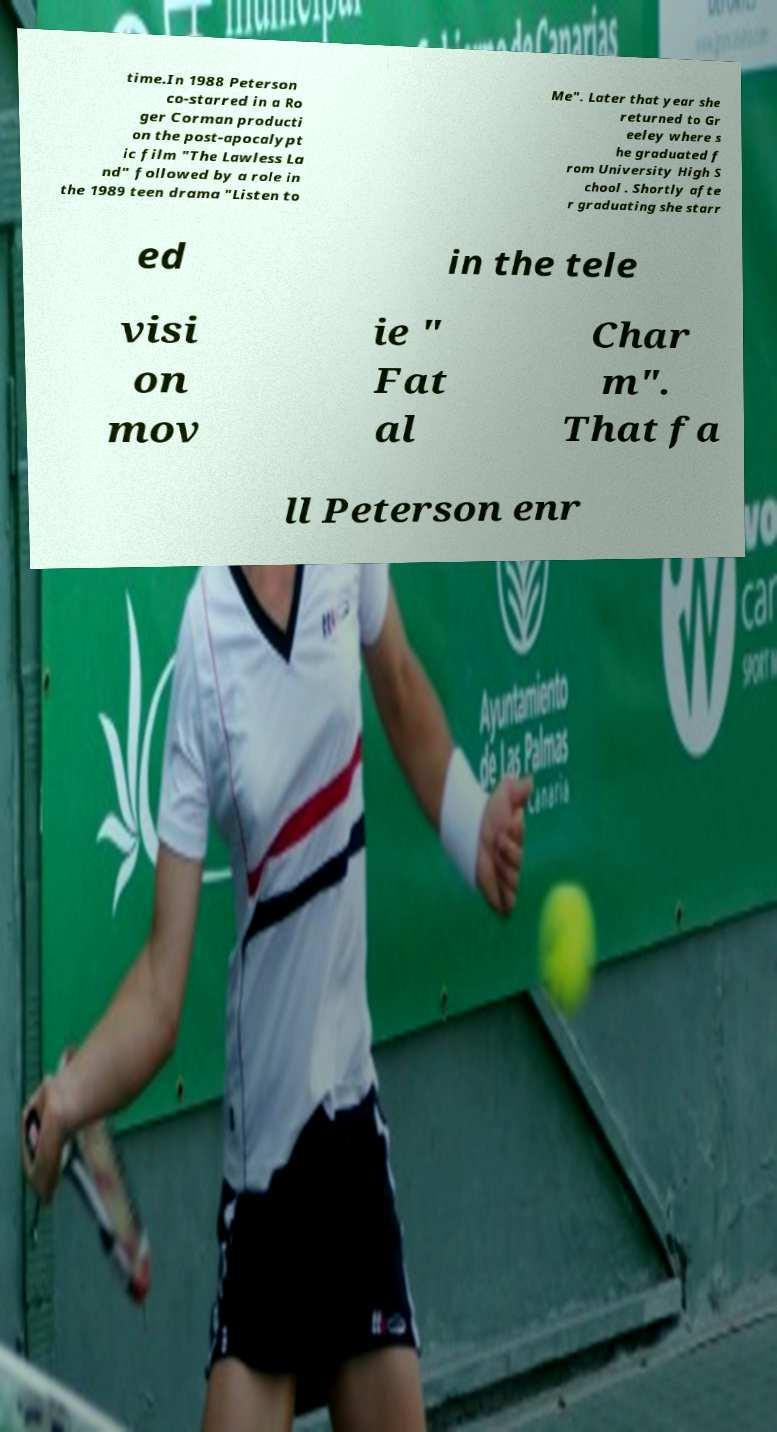Could you assist in decoding the text presented in this image and type it out clearly? time.In 1988 Peterson co-starred in a Ro ger Corman producti on the post-apocalypt ic film "The Lawless La nd" followed by a role in the 1989 teen drama "Listen to Me". Later that year she returned to Gr eeley where s he graduated f rom University High S chool . Shortly afte r graduating she starr ed in the tele visi on mov ie " Fat al Char m". That fa ll Peterson enr 